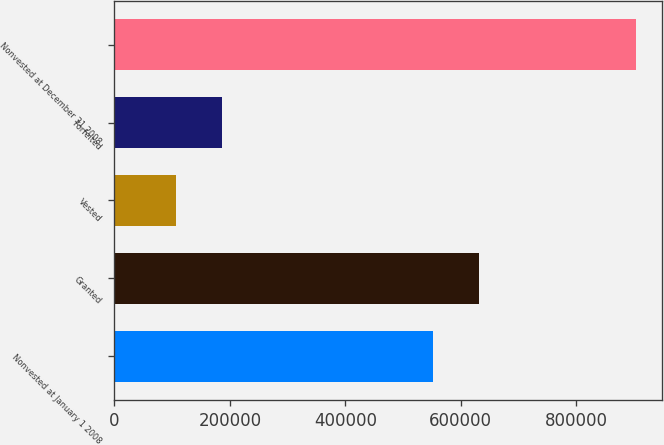Convert chart. <chart><loc_0><loc_0><loc_500><loc_500><bar_chart><fcel>Nonvested at January 1 2008<fcel>Granted<fcel>Vested<fcel>Forfeited<fcel>Nonvested at December 31 2008<nl><fcel>551664<fcel>631348<fcel>106365<fcel>186048<fcel>903200<nl></chart> 